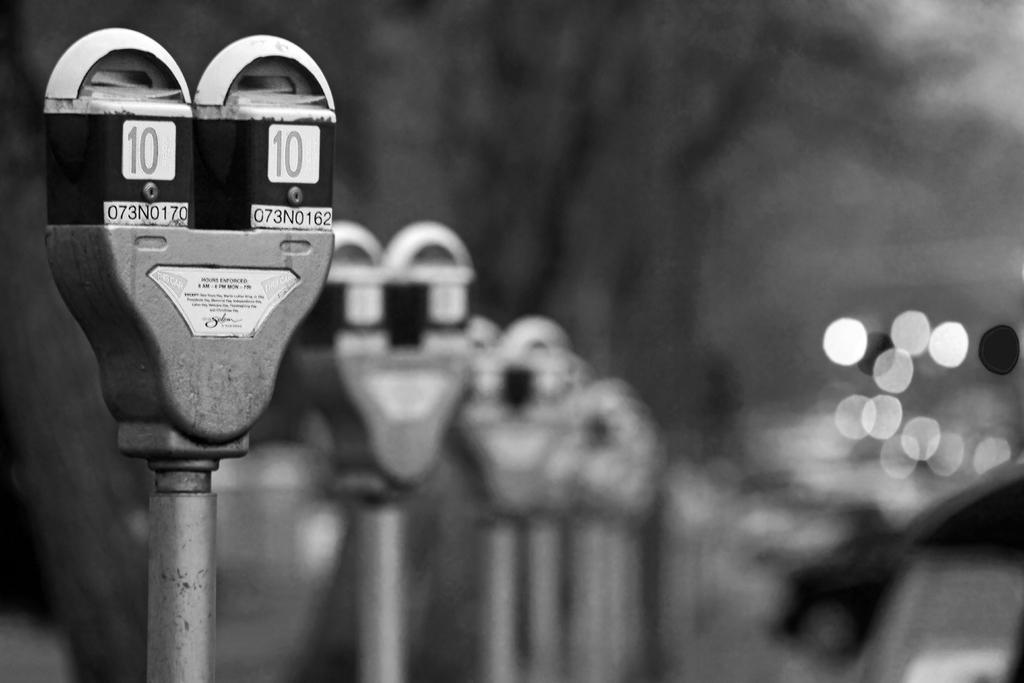<image>
Summarize the visual content of the image. A black and white picture of parking meters with meter number 10 at the forefront. 